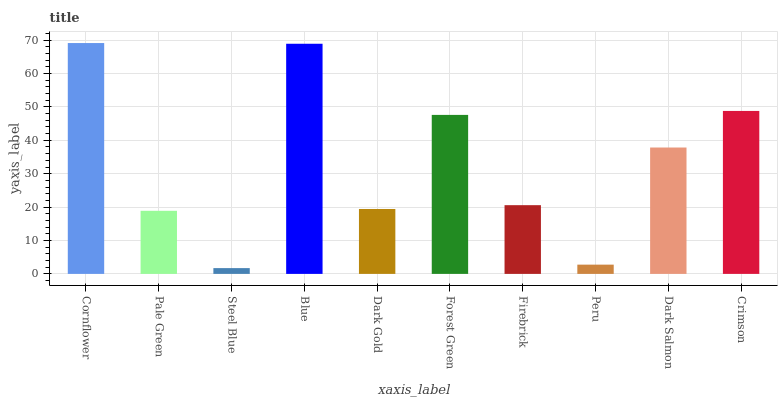Is Steel Blue the minimum?
Answer yes or no. Yes. Is Cornflower the maximum?
Answer yes or no. Yes. Is Pale Green the minimum?
Answer yes or no. No. Is Pale Green the maximum?
Answer yes or no. No. Is Cornflower greater than Pale Green?
Answer yes or no. Yes. Is Pale Green less than Cornflower?
Answer yes or no. Yes. Is Pale Green greater than Cornflower?
Answer yes or no. No. Is Cornflower less than Pale Green?
Answer yes or no. No. Is Dark Salmon the high median?
Answer yes or no. Yes. Is Firebrick the low median?
Answer yes or no. Yes. Is Pale Green the high median?
Answer yes or no. No. Is Blue the low median?
Answer yes or no. No. 